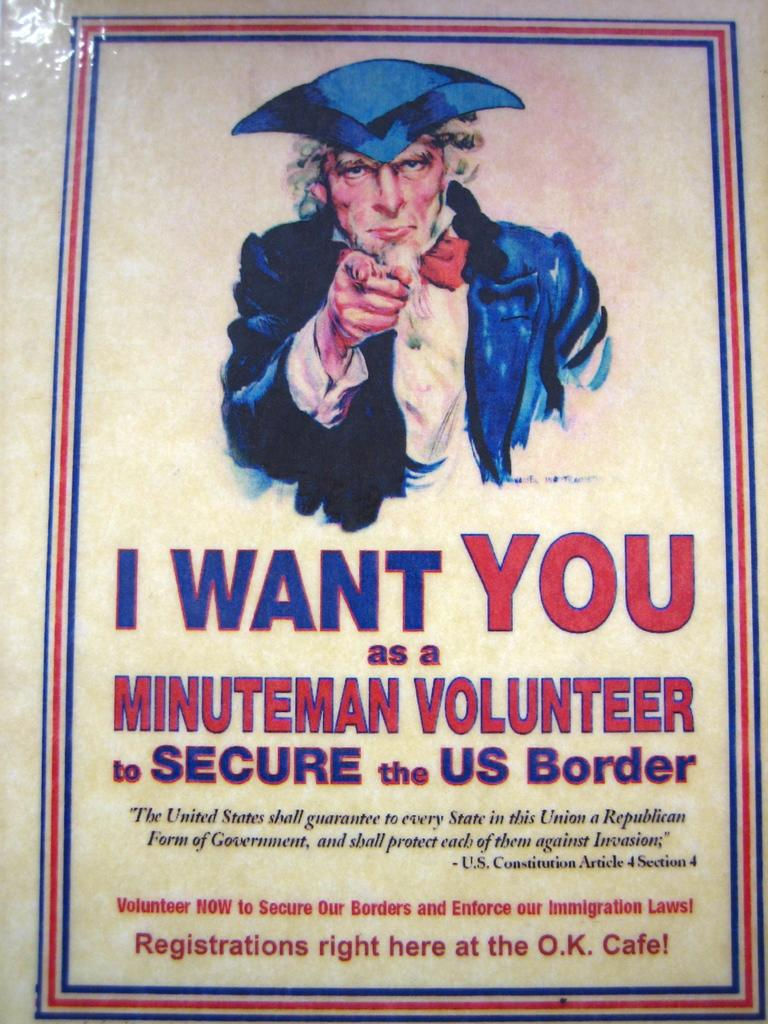What is the main object in the image? There is a pamphlet in the image. What is the color of the pamphlet? The pamphlet is cream in color. What can be seen on the pamphlet? There is a person depicted on the pamphlet. What colors are used for the text on the pamphlet? The text on the pamphlet is written in red and blue colors. What type of bag is the person holding in the image? There is no person holding a bag in the image; the image only shows a pamphlet. 